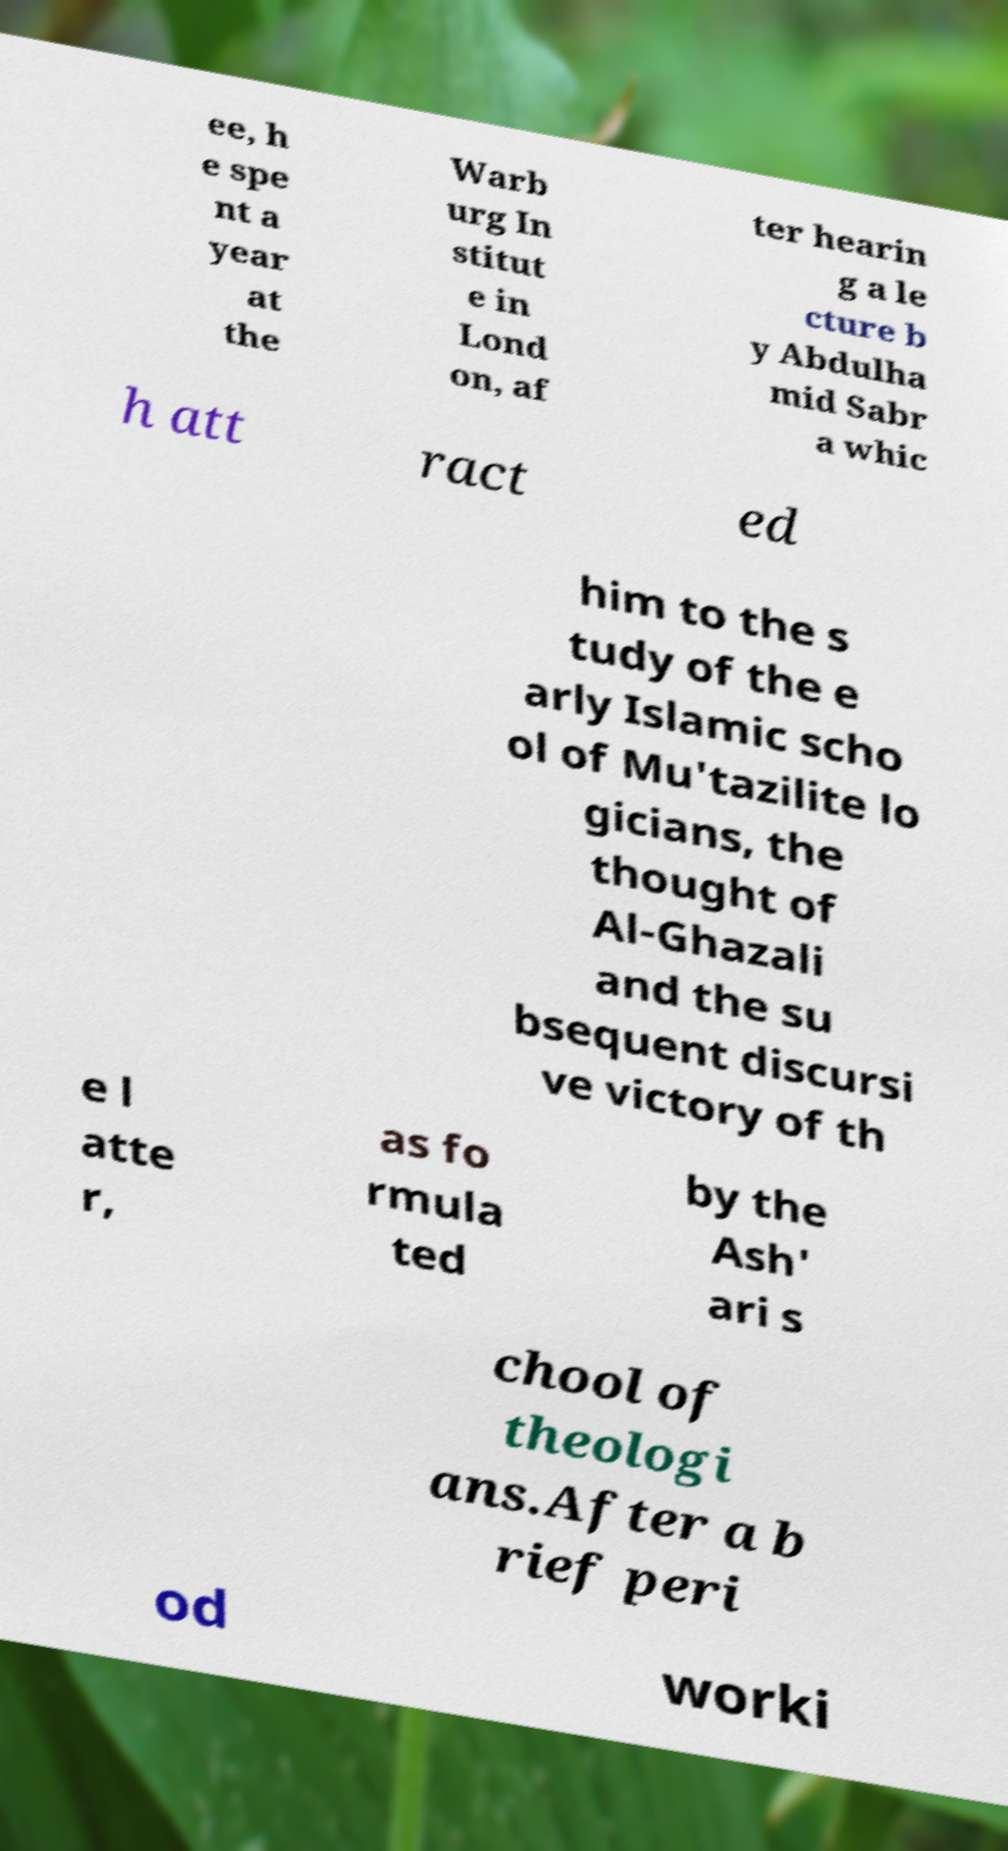Could you extract and type out the text from this image? ee, h e spe nt a year at the Warb urg In stitut e in Lond on, af ter hearin g a le cture b y Abdulha mid Sabr a whic h att ract ed him to the s tudy of the e arly Islamic scho ol of Mu'tazilite lo gicians, the thought of Al-Ghazali and the su bsequent discursi ve victory of th e l atte r, as fo rmula ted by the Ash' ari s chool of theologi ans.After a b rief peri od worki 